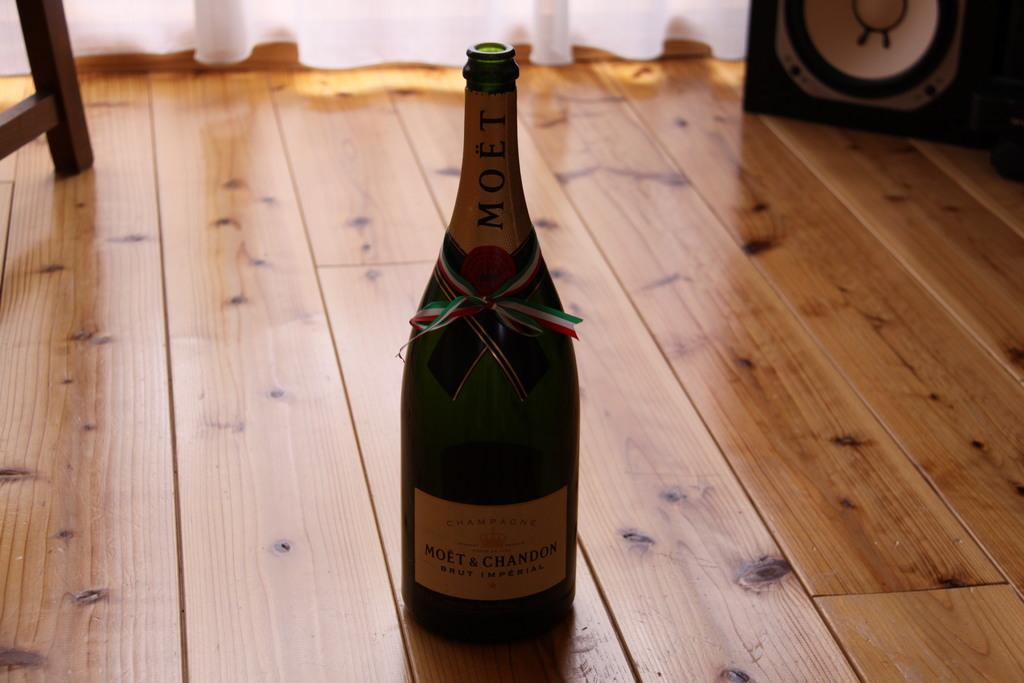Provide a one-sentence caption for the provided image. Bottle of Moet & Chandon wine is on a wooden floor. 